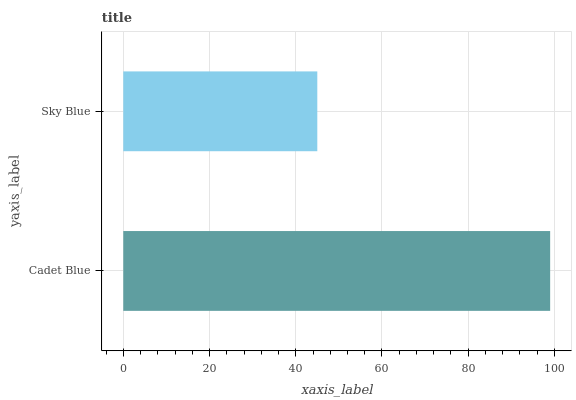Is Sky Blue the minimum?
Answer yes or no. Yes. Is Cadet Blue the maximum?
Answer yes or no. Yes. Is Sky Blue the maximum?
Answer yes or no. No. Is Cadet Blue greater than Sky Blue?
Answer yes or no. Yes. Is Sky Blue less than Cadet Blue?
Answer yes or no. Yes. Is Sky Blue greater than Cadet Blue?
Answer yes or no. No. Is Cadet Blue less than Sky Blue?
Answer yes or no. No. Is Cadet Blue the high median?
Answer yes or no. Yes. Is Sky Blue the low median?
Answer yes or no. Yes. Is Sky Blue the high median?
Answer yes or no. No. Is Cadet Blue the low median?
Answer yes or no. No. 